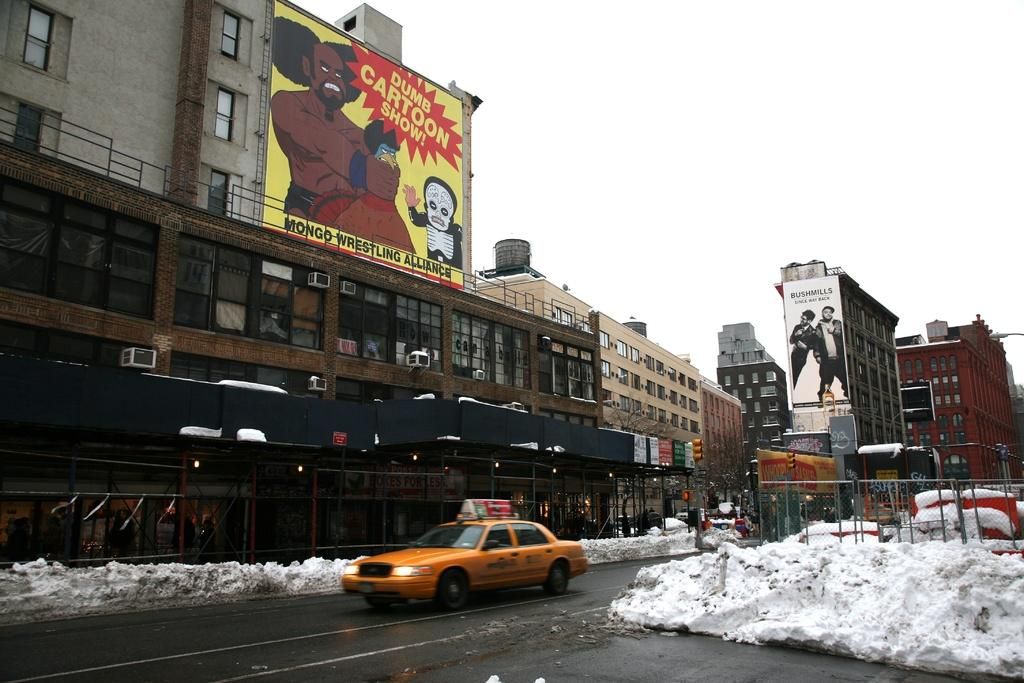Provide a one-sentence caption for the provided image. a sign for a dumb cartoon show that is above the ground. 